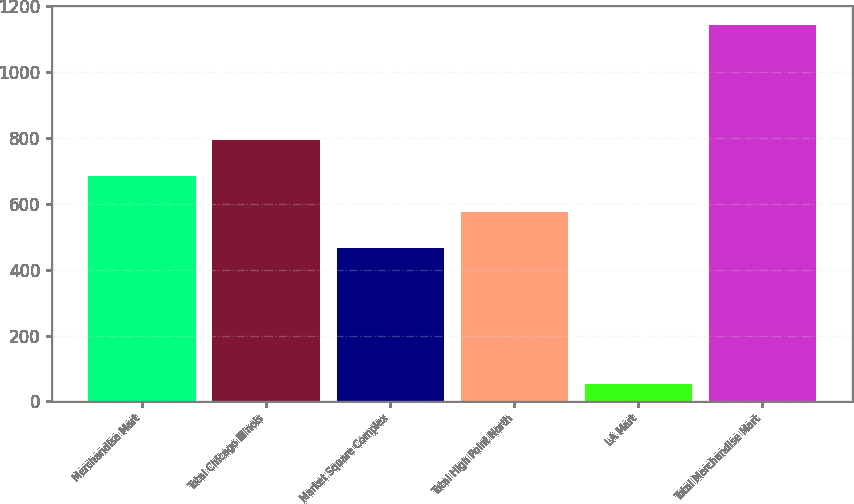<chart> <loc_0><loc_0><loc_500><loc_500><bar_chart><fcel>Merchandise Mart<fcel>Total Chicago Illinois<fcel>Market Square Complex<fcel>Total High Point North<fcel>LA Mart<fcel>Total Merchandise Mart<nl><fcel>684.2<fcel>793.3<fcel>466<fcel>575.1<fcel>54<fcel>1145<nl></chart> 